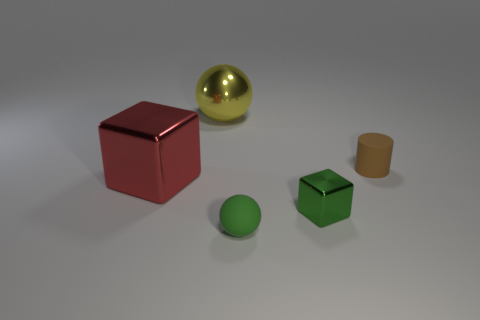How many other things are there of the same color as the large cube?
Your response must be concise. 0. Are there more red cubes that are on the right side of the tiny metallic object than matte cylinders?
Offer a very short reply. No. There is a red object that is the same size as the yellow shiny sphere; what is it made of?
Provide a short and direct response. Metal. Are there any other things that have the same size as the red shiny object?
Offer a terse response. Yes. What size is the matte thing left of the brown thing?
Ensure brevity in your answer.  Small. The green metal cube is what size?
Provide a short and direct response. Small. How many blocks are either large blue objects or large shiny objects?
Give a very brief answer. 1. There is a sphere that is made of the same material as the red thing; what is its size?
Provide a short and direct response. Large. What number of matte spheres have the same color as the matte cylinder?
Offer a very short reply. 0. Are there any rubber things behind the matte ball?
Your answer should be compact. Yes. 